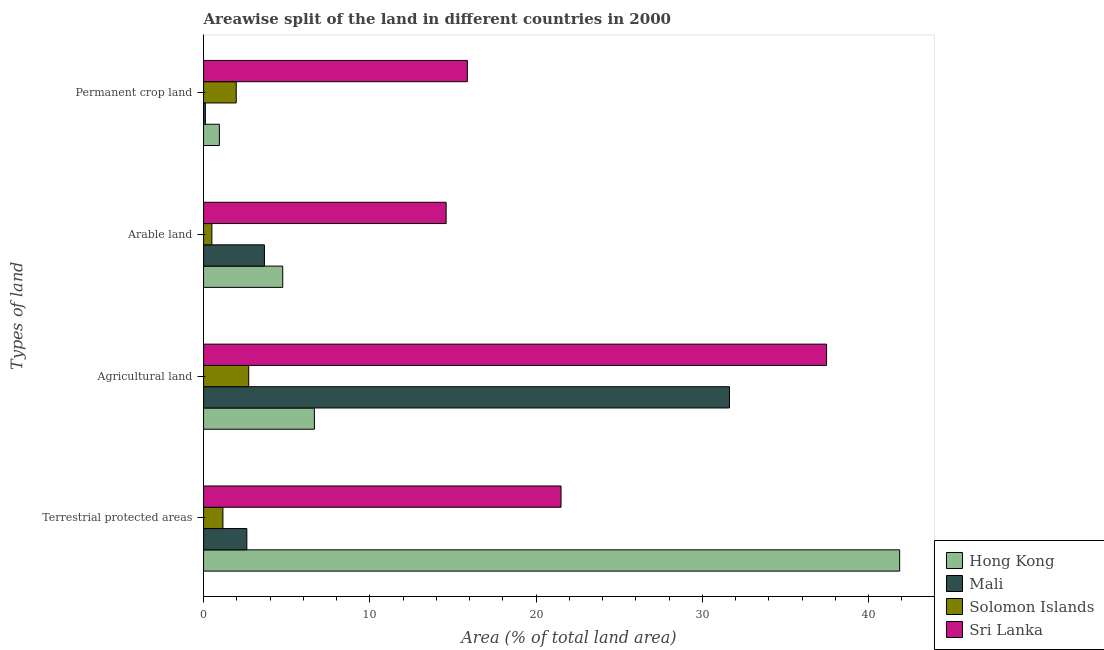How many different coloured bars are there?
Your answer should be compact. 4. Are the number of bars per tick equal to the number of legend labels?
Provide a succinct answer. Yes. How many bars are there on the 1st tick from the bottom?
Ensure brevity in your answer.  4. What is the label of the 4th group of bars from the top?
Your response must be concise. Terrestrial protected areas. What is the percentage of area under agricultural land in Hong Kong?
Provide a succinct answer. 6.67. Across all countries, what is the maximum percentage of area under arable land?
Your response must be concise. 14.59. Across all countries, what is the minimum percentage of area under permanent crop land?
Offer a very short reply. 0.11. In which country was the percentage of area under arable land maximum?
Provide a succinct answer. Sri Lanka. In which country was the percentage of land under terrestrial protection minimum?
Offer a terse response. Solomon Islands. What is the total percentage of area under permanent crop land in the graph?
Ensure brevity in your answer.  18.89. What is the difference between the percentage of area under arable land in Mali and that in Solomon Islands?
Your response must be concise. 3.16. What is the difference between the percentage of area under permanent crop land in Sri Lanka and the percentage of area under arable land in Solomon Islands?
Your answer should be very brief. 15.37. What is the average percentage of area under arable land per country?
Provide a succinct answer. 5.88. What is the difference between the percentage of area under arable land and percentage of area under permanent crop land in Hong Kong?
Your response must be concise. 3.81. What is the ratio of the percentage of area under permanent crop land in Sri Lanka to that in Mali?
Offer a terse response. 146.67. Is the percentage of area under agricultural land in Mali less than that in Hong Kong?
Keep it short and to the point. No. What is the difference between the highest and the second highest percentage of land under terrestrial protection?
Your answer should be compact. 20.37. What is the difference between the highest and the lowest percentage of area under permanent crop land?
Give a very brief answer. 15.76. Is it the case that in every country, the sum of the percentage of area under permanent crop land and percentage of land under terrestrial protection is greater than the sum of percentage of area under arable land and percentage of area under agricultural land?
Give a very brief answer. No. What does the 1st bar from the top in Terrestrial protected areas represents?
Your response must be concise. Sri Lanka. What does the 2nd bar from the bottom in Arable land represents?
Give a very brief answer. Mali. Is it the case that in every country, the sum of the percentage of land under terrestrial protection and percentage of area under agricultural land is greater than the percentage of area under arable land?
Provide a succinct answer. Yes. How many countries are there in the graph?
Your answer should be very brief. 4. What is the difference between two consecutive major ticks on the X-axis?
Provide a short and direct response. 10. Does the graph contain any zero values?
Your answer should be very brief. No. Does the graph contain grids?
Give a very brief answer. No. How many legend labels are there?
Keep it short and to the point. 4. How are the legend labels stacked?
Provide a succinct answer. Vertical. What is the title of the graph?
Offer a very short reply. Areawise split of the land in different countries in 2000. Does "United Kingdom" appear as one of the legend labels in the graph?
Offer a terse response. No. What is the label or title of the X-axis?
Keep it short and to the point. Area (% of total land area). What is the label or title of the Y-axis?
Make the answer very short. Types of land. What is the Area (% of total land area) in Hong Kong in Terrestrial protected areas?
Ensure brevity in your answer.  41.87. What is the Area (% of total land area) of Mali in Terrestrial protected areas?
Your answer should be very brief. 2.6. What is the Area (% of total land area) of Solomon Islands in Terrestrial protected areas?
Provide a short and direct response. 1.16. What is the Area (% of total land area) of Sri Lanka in Terrestrial protected areas?
Keep it short and to the point. 21.5. What is the Area (% of total land area) in Hong Kong in Agricultural land?
Give a very brief answer. 6.67. What is the Area (% of total land area) of Mali in Agricultural land?
Your response must be concise. 31.63. What is the Area (% of total land area) of Solomon Islands in Agricultural land?
Provide a succinct answer. 2.72. What is the Area (% of total land area) of Sri Lanka in Agricultural land?
Offer a very short reply. 37.47. What is the Area (% of total land area) in Hong Kong in Arable land?
Offer a very short reply. 4.76. What is the Area (% of total land area) of Mali in Arable land?
Offer a very short reply. 3.66. What is the Area (% of total land area) of Solomon Islands in Arable land?
Offer a very short reply. 0.5. What is the Area (% of total land area) in Sri Lanka in Arable land?
Your answer should be compact. 14.59. What is the Area (% of total land area) of Hong Kong in Permanent crop land?
Your answer should be very brief. 0.95. What is the Area (% of total land area) in Mali in Permanent crop land?
Your response must be concise. 0.11. What is the Area (% of total land area) of Solomon Islands in Permanent crop land?
Make the answer very short. 1.96. What is the Area (% of total land area) of Sri Lanka in Permanent crop land?
Offer a terse response. 15.87. Across all Types of land, what is the maximum Area (% of total land area) in Hong Kong?
Offer a terse response. 41.87. Across all Types of land, what is the maximum Area (% of total land area) in Mali?
Ensure brevity in your answer.  31.63. Across all Types of land, what is the maximum Area (% of total land area) in Solomon Islands?
Offer a very short reply. 2.72. Across all Types of land, what is the maximum Area (% of total land area) in Sri Lanka?
Offer a very short reply. 37.47. Across all Types of land, what is the minimum Area (% of total land area) of Hong Kong?
Your response must be concise. 0.95. Across all Types of land, what is the minimum Area (% of total land area) in Mali?
Offer a very short reply. 0.11. Across all Types of land, what is the minimum Area (% of total land area) of Solomon Islands?
Make the answer very short. 0.5. Across all Types of land, what is the minimum Area (% of total land area) in Sri Lanka?
Ensure brevity in your answer.  14.59. What is the total Area (% of total land area) of Hong Kong in the graph?
Make the answer very short. 54.25. What is the total Area (% of total land area) of Mali in the graph?
Give a very brief answer. 38.01. What is the total Area (% of total land area) of Solomon Islands in the graph?
Your answer should be compact. 6.34. What is the total Area (% of total land area) of Sri Lanka in the graph?
Provide a succinct answer. 89.43. What is the difference between the Area (% of total land area) in Hong Kong in Terrestrial protected areas and that in Agricultural land?
Offer a very short reply. 35.2. What is the difference between the Area (% of total land area) in Mali in Terrestrial protected areas and that in Agricultural land?
Your answer should be compact. -29.03. What is the difference between the Area (% of total land area) of Solomon Islands in Terrestrial protected areas and that in Agricultural land?
Your answer should be compact. -1.55. What is the difference between the Area (% of total land area) in Sri Lanka in Terrestrial protected areas and that in Agricultural land?
Provide a succinct answer. -15.97. What is the difference between the Area (% of total land area) in Hong Kong in Terrestrial protected areas and that in Arable land?
Your answer should be very brief. 37.11. What is the difference between the Area (% of total land area) in Mali in Terrestrial protected areas and that in Arable land?
Offer a very short reply. -1.06. What is the difference between the Area (% of total land area) in Solomon Islands in Terrestrial protected areas and that in Arable land?
Your response must be concise. 0.66. What is the difference between the Area (% of total land area) in Sri Lanka in Terrestrial protected areas and that in Arable land?
Ensure brevity in your answer.  6.91. What is the difference between the Area (% of total land area) in Hong Kong in Terrestrial protected areas and that in Permanent crop land?
Keep it short and to the point. 40.92. What is the difference between the Area (% of total land area) in Mali in Terrestrial protected areas and that in Permanent crop land?
Give a very brief answer. 2.5. What is the difference between the Area (% of total land area) of Solomon Islands in Terrestrial protected areas and that in Permanent crop land?
Keep it short and to the point. -0.8. What is the difference between the Area (% of total land area) of Sri Lanka in Terrestrial protected areas and that in Permanent crop land?
Offer a terse response. 5.63. What is the difference between the Area (% of total land area) in Hong Kong in Agricultural land and that in Arable land?
Offer a very short reply. 1.9. What is the difference between the Area (% of total land area) in Mali in Agricultural land and that in Arable land?
Your response must be concise. 27.97. What is the difference between the Area (% of total land area) in Solomon Islands in Agricultural land and that in Arable land?
Your answer should be compact. 2.22. What is the difference between the Area (% of total land area) in Sri Lanka in Agricultural land and that in Arable land?
Your answer should be very brief. 22.88. What is the difference between the Area (% of total land area) in Hong Kong in Agricultural land and that in Permanent crop land?
Ensure brevity in your answer.  5.71. What is the difference between the Area (% of total land area) of Mali in Agricultural land and that in Permanent crop land?
Your answer should be compact. 31.53. What is the difference between the Area (% of total land area) of Solomon Islands in Agricultural land and that in Permanent crop land?
Offer a very short reply. 0.75. What is the difference between the Area (% of total land area) in Sri Lanka in Agricultural land and that in Permanent crop land?
Provide a short and direct response. 21.61. What is the difference between the Area (% of total land area) in Hong Kong in Arable land and that in Permanent crop land?
Provide a short and direct response. 3.81. What is the difference between the Area (% of total land area) of Mali in Arable land and that in Permanent crop land?
Offer a very short reply. 3.55. What is the difference between the Area (% of total land area) in Solomon Islands in Arable land and that in Permanent crop land?
Provide a succinct answer. -1.46. What is the difference between the Area (% of total land area) of Sri Lanka in Arable land and that in Permanent crop land?
Your answer should be very brief. -1.28. What is the difference between the Area (% of total land area) in Hong Kong in Terrestrial protected areas and the Area (% of total land area) in Mali in Agricultural land?
Make the answer very short. 10.24. What is the difference between the Area (% of total land area) of Hong Kong in Terrestrial protected areas and the Area (% of total land area) of Solomon Islands in Agricultural land?
Offer a terse response. 39.16. What is the difference between the Area (% of total land area) in Hong Kong in Terrestrial protected areas and the Area (% of total land area) in Sri Lanka in Agricultural land?
Keep it short and to the point. 4.4. What is the difference between the Area (% of total land area) of Mali in Terrestrial protected areas and the Area (% of total land area) of Solomon Islands in Agricultural land?
Provide a succinct answer. -0.11. What is the difference between the Area (% of total land area) in Mali in Terrestrial protected areas and the Area (% of total land area) in Sri Lanka in Agricultural land?
Provide a succinct answer. -34.87. What is the difference between the Area (% of total land area) of Solomon Islands in Terrestrial protected areas and the Area (% of total land area) of Sri Lanka in Agricultural land?
Offer a very short reply. -36.31. What is the difference between the Area (% of total land area) of Hong Kong in Terrestrial protected areas and the Area (% of total land area) of Mali in Arable land?
Provide a short and direct response. 38.21. What is the difference between the Area (% of total land area) in Hong Kong in Terrestrial protected areas and the Area (% of total land area) in Solomon Islands in Arable land?
Provide a succinct answer. 41.37. What is the difference between the Area (% of total land area) of Hong Kong in Terrestrial protected areas and the Area (% of total land area) of Sri Lanka in Arable land?
Your answer should be very brief. 27.28. What is the difference between the Area (% of total land area) of Mali in Terrestrial protected areas and the Area (% of total land area) of Solomon Islands in Arable land?
Offer a very short reply. 2.1. What is the difference between the Area (% of total land area) of Mali in Terrestrial protected areas and the Area (% of total land area) of Sri Lanka in Arable land?
Provide a short and direct response. -11.99. What is the difference between the Area (% of total land area) in Solomon Islands in Terrestrial protected areas and the Area (% of total land area) in Sri Lanka in Arable land?
Your answer should be compact. -13.43. What is the difference between the Area (% of total land area) in Hong Kong in Terrestrial protected areas and the Area (% of total land area) in Mali in Permanent crop land?
Keep it short and to the point. 41.76. What is the difference between the Area (% of total land area) of Hong Kong in Terrestrial protected areas and the Area (% of total land area) of Solomon Islands in Permanent crop land?
Give a very brief answer. 39.91. What is the difference between the Area (% of total land area) of Hong Kong in Terrestrial protected areas and the Area (% of total land area) of Sri Lanka in Permanent crop land?
Your answer should be compact. 26. What is the difference between the Area (% of total land area) in Mali in Terrestrial protected areas and the Area (% of total land area) in Solomon Islands in Permanent crop land?
Ensure brevity in your answer.  0.64. What is the difference between the Area (% of total land area) in Mali in Terrestrial protected areas and the Area (% of total land area) in Sri Lanka in Permanent crop land?
Ensure brevity in your answer.  -13.26. What is the difference between the Area (% of total land area) of Solomon Islands in Terrestrial protected areas and the Area (% of total land area) of Sri Lanka in Permanent crop land?
Your answer should be very brief. -14.7. What is the difference between the Area (% of total land area) in Hong Kong in Agricultural land and the Area (% of total land area) in Mali in Arable land?
Keep it short and to the point. 3. What is the difference between the Area (% of total land area) of Hong Kong in Agricultural land and the Area (% of total land area) of Solomon Islands in Arable land?
Provide a short and direct response. 6.17. What is the difference between the Area (% of total land area) of Hong Kong in Agricultural land and the Area (% of total land area) of Sri Lanka in Arable land?
Offer a very short reply. -7.92. What is the difference between the Area (% of total land area) in Mali in Agricultural land and the Area (% of total land area) in Solomon Islands in Arable land?
Provide a short and direct response. 31.13. What is the difference between the Area (% of total land area) in Mali in Agricultural land and the Area (% of total land area) in Sri Lanka in Arable land?
Offer a very short reply. 17.04. What is the difference between the Area (% of total land area) of Solomon Islands in Agricultural land and the Area (% of total land area) of Sri Lanka in Arable land?
Provide a succinct answer. -11.88. What is the difference between the Area (% of total land area) of Hong Kong in Agricultural land and the Area (% of total land area) of Mali in Permanent crop land?
Provide a succinct answer. 6.56. What is the difference between the Area (% of total land area) in Hong Kong in Agricultural land and the Area (% of total land area) in Solomon Islands in Permanent crop land?
Ensure brevity in your answer.  4.7. What is the difference between the Area (% of total land area) of Hong Kong in Agricultural land and the Area (% of total land area) of Sri Lanka in Permanent crop land?
Give a very brief answer. -9.2. What is the difference between the Area (% of total land area) of Mali in Agricultural land and the Area (% of total land area) of Solomon Islands in Permanent crop land?
Provide a succinct answer. 29.67. What is the difference between the Area (% of total land area) in Mali in Agricultural land and the Area (% of total land area) in Sri Lanka in Permanent crop land?
Give a very brief answer. 15.77. What is the difference between the Area (% of total land area) in Solomon Islands in Agricultural land and the Area (% of total land area) in Sri Lanka in Permanent crop land?
Give a very brief answer. -13.15. What is the difference between the Area (% of total land area) in Hong Kong in Arable land and the Area (% of total land area) in Mali in Permanent crop land?
Offer a terse response. 4.65. What is the difference between the Area (% of total land area) of Hong Kong in Arable land and the Area (% of total land area) of Solomon Islands in Permanent crop land?
Give a very brief answer. 2.8. What is the difference between the Area (% of total land area) in Hong Kong in Arable land and the Area (% of total land area) in Sri Lanka in Permanent crop land?
Keep it short and to the point. -11.1. What is the difference between the Area (% of total land area) of Mali in Arable land and the Area (% of total land area) of Solomon Islands in Permanent crop land?
Your answer should be compact. 1.7. What is the difference between the Area (% of total land area) in Mali in Arable land and the Area (% of total land area) in Sri Lanka in Permanent crop land?
Offer a terse response. -12.21. What is the difference between the Area (% of total land area) of Solomon Islands in Arable land and the Area (% of total land area) of Sri Lanka in Permanent crop land?
Offer a terse response. -15.37. What is the average Area (% of total land area) of Hong Kong per Types of land?
Offer a terse response. 13.56. What is the average Area (% of total land area) in Mali per Types of land?
Give a very brief answer. 9.5. What is the average Area (% of total land area) in Solomon Islands per Types of land?
Provide a short and direct response. 1.59. What is the average Area (% of total land area) in Sri Lanka per Types of land?
Your response must be concise. 22.36. What is the difference between the Area (% of total land area) of Hong Kong and Area (% of total land area) of Mali in Terrestrial protected areas?
Offer a terse response. 39.27. What is the difference between the Area (% of total land area) in Hong Kong and Area (% of total land area) in Solomon Islands in Terrestrial protected areas?
Provide a short and direct response. 40.71. What is the difference between the Area (% of total land area) in Hong Kong and Area (% of total land area) in Sri Lanka in Terrestrial protected areas?
Provide a short and direct response. 20.37. What is the difference between the Area (% of total land area) in Mali and Area (% of total land area) in Solomon Islands in Terrestrial protected areas?
Ensure brevity in your answer.  1.44. What is the difference between the Area (% of total land area) of Mali and Area (% of total land area) of Sri Lanka in Terrestrial protected areas?
Give a very brief answer. -18.9. What is the difference between the Area (% of total land area) of Solomon Islands and Area (% of total land area) of Sri Lanka in Terrestrial protected areas?
Make the answer very short. -20.34. What is the difference between the Area (% of total land area) in Hong Kong and Area (% of total land area) in Mali in Agricultural land?
Offer a terse response. -24.97. What is the difference between the Area (% of total land area) of Hong Kong and Area (% of total land area) of Solomon Islands in Agricultural land?
Offer a terse response. 3.95. What is the difference between the Area (% of total land area) of Hong Kong and Area (% of total land area) of Sri Lanka in Agricultural land?
Keep it short and to the point. -30.81. What is the difference between the Area (% of total land area) of Mali and Area (% of total land area) of Solomon Islands in Agricultural land?
Provide a succinct answer. 28.92. What is the difference between the Area (% of total land area) of Mali and Area (% of total land area) of Sri Lanka in Agricultural land?
Make the answer very short. -5.84. What is the difference between the Area (% of total land area) in Solomon Islands and Area (% of total land area) in Sri Lanka in Agricultural land?
Offer a very short reply. -34.76. What is the difference between the Area (% of total land area) of Hong Kong and Area (% of total land area) of Mali in Arable land?
Keep it short and to the point. 1.1. What is the difference between the Area (% of total land area) in Hong Kong and Area (% of total land area) in Solomon Islands in Arable land?
Your answer should be compact. 4.26. What is the difference between the Area (% of total land area) in Hong Kong and Area (% of total land area) in Sri Lanka in Arable land?
Give a very brief answer. -9.83. What is the difference between the Area (% of total land area) of Mali and Area (% of total land area) of Solomon Islands in Arable land?
Provide a succinct answer. 3.16. What is the difference between the Area (% of total land area) of Mali and Area (% of total land area) of Sri Lanka in Arable land?
Offer a terse response. -10.93. What is the difference between the Area (% of total land area) in Solomon Islands and Area (% of total land area) in Sri Lanka in Arable land?
Keep it short and to the point. -14.09. What is the difference between the Area (% of total land area) in Hong Kong and Area (% of total land area) in Mali in Permanent crop land?
Your answer should be compact. 0.84. What is the difference between the Area (% of total land area) of Hong Kong and Area (% of total land area) of Solomon Islands in Permanent crop land?
Provide a short and direct response. -1.01. What is the difference between the Area (% of total land area) in Hong Kong and Area (% of total land area) in Sri Lanka in Permanent crop land?
Offer a terse response. -14.91. What is the difference between the Area (% of total land area) in Mali and Area (% of total land area) in Solomon Islands in Permanent crop land?
Ensure brevity in your answer.  -1.86. What is the difference between the Area (% of total land area) in Mali and Area (% of total land area) in Sri Lanka in Permanent crop land?
Provide a short and direct response. -15.76. What is the difference between the Area (% of total land area) of Solomon Islands and Area (% of total land area) of Sri Lanka in Permanent crop land?
Your answer should be compact. -13.9. What is the ratio of the Area (% of total land area) in Hong Kong in Terrestrial protected areas to that in Agricultural land?
Your response must be concise. 6.28. What is the ratio of the Area (% of total land area) in Mali in Terrestrial protected areas to that in Agricultural land?
Your answer should be compact. 0.08. What is the ratio of the Area (% of total land area) in Solomon Islands in Terrestrial protected areas to that in Agricultural land?
Provide a succinct answer. 0.43. What is the ratio of the Area (% of total land area) of Sri Lanka in Terrestrial protected areas to that in Agricultural land?
Your response must be concise. 0.57. What is the ratio of the Area (% of total land area) in Hong Kong in Terrestrial protected areas to that in Arable land?
Your answer should be very brief. 8.79. What is the ratio of the Area (% of total land area) in Mali in Terrestrial protected areas to that in Arable land?
Your answer should be compact. 0.71. What is the ratio of the Area (% of total land area) in Solomon Islands in Terrestrial protected areas to that in Arable land?
Give a very brief answer. 2.33. What is the ratio of the Area (% of total land area) of Sri Lanka in Terrestrial protected areas to that in Arable land?
Provide a short and direct response. 1.47. What is the ratio of the Area (% of total land area) of Hong Kong in Terrestrial protected areas to that in Permanent crop land?
Provide a succinct answer. 43.96. What is the ratio of the Area (% of total land area) of Mali in Terrestrial protected areas to that in Permanent crop land?
Make the answer very short. 24.07. What is the ratio of the Area (% of total land area) of Solomon Islands in Terrestrial protected areas to that in Permanent crop land?
Your response must be concise. 0.59. What is the ratio of the Area (% of total land area) of Sri Lanka in Terrestrial protected areas to that in Permanent crop land?
Provide a succinct answer. 1.36. What is the ratio of the Area (% of total land area) of Hong Kong in Agricultural land to that in Arable land?
Keep it short and to the point. 1.4. What is the ratio of the Area (% of total land area) of Mali in Agricultural land to that in Arable land?
Offer a terse response. 8.64. What is the ratio of the Area (% of total land area) of Solomon Islands in Agricultural land to that in Arable land?
Ensure brevity in your answer.  5.43. What is the ratio of the Area (% of total land area) in Sri Lanka in Agricultural land to that in Arable land?
Your response must be concise. 2.57. What is the ratio of the Area (% of total land area) in Mali in Agricultural land to that in Permanent crop land?
Make the answer very short. 292.42. What is the ratio of the Area (% of total land area) of Solomon Islands in Agricultural land to that in Permanent crop land?
Offer a very short reply. 1.38. What is the ratio of the Area (% of total land area) of Sri Lanka in Agricultural land to that in Permanent crop land?
Provide a short and direct response. 2.36. What is the ratio of the Area (% of total land area) in Hong Kong in Arable land to that in Permanent crop land?
Your answer should be compact. 5. What is the ratio of the Area (% of total land area) in Mali in Arable land to that in Permanent crop land?
Offer a terse response. 33.85. What is the ratio of the Area (% of total land area) of Solomon Islands in Arable land to that in Permanent crop land?
Ensure brevity in your answer.  0.25. What is the ratio of the Area (% of total land area) of Sri Lanka in Arable land to that in Permanent crop land?
Provide a short and direct response. 0.92. What is the difference between the highest and the second highest Area (% of total land area) in Hong Kong?
Make the answer very short. 35.2. What is the difference between the highest and the second highest Area (% of total land area) of Mali?
Offer a terse response. 27.97. What is the difference between the highest and the second highest Area (% of total land area) in Solomon Islands?
Keep it short and to the point. 0.75. What is the difference between the highest and the second highest Area (% of total land area) in Sri Lanka?
Your response must be concise. 15.97. What is the difference between the highest and the lowest Area (% of total land area) in Hong Kong?
Provide a succinct answer. 40.92. What is the difference between the highest and the lowest Area (% of total land area) in Mali?
Your answer should be compact. 31.53. What is the difference between the highest and the lowest Area (% of total land area) in Solomon Islands?
Provide a succinct answer. 2.22. What is the difference between the highest and the lowest Area (% of total land area) of Sri Lanka?
Provide a succinct answer. 22.88. 